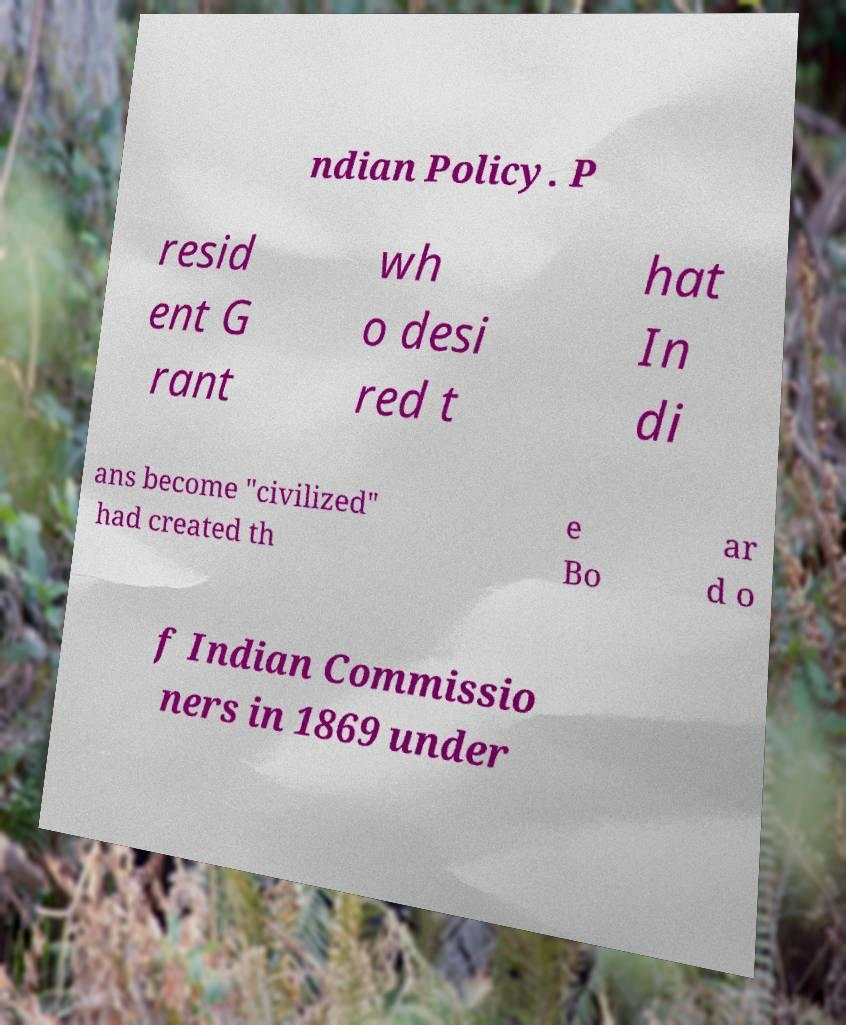Can you read and provide the text displayed in the image?This photo seems to have some interesting text. Can you extract and type it out for me? ndian Policy. P resid ent G rant wh o desi red t hat In di ans become "civilized" had created th e Bo ar d o f Indian Commissio ners in 1869 under 